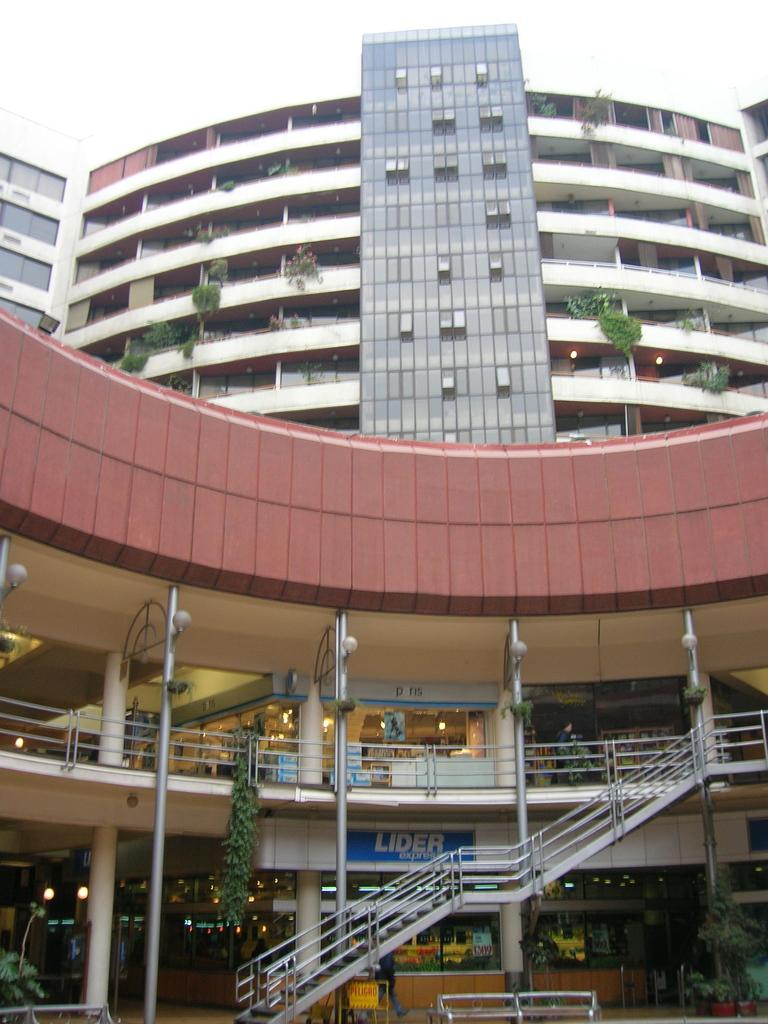<image>
Create a compact narrative representing the image presented. the outside of a building with stairs and a sign behind them that says 'lider express' 